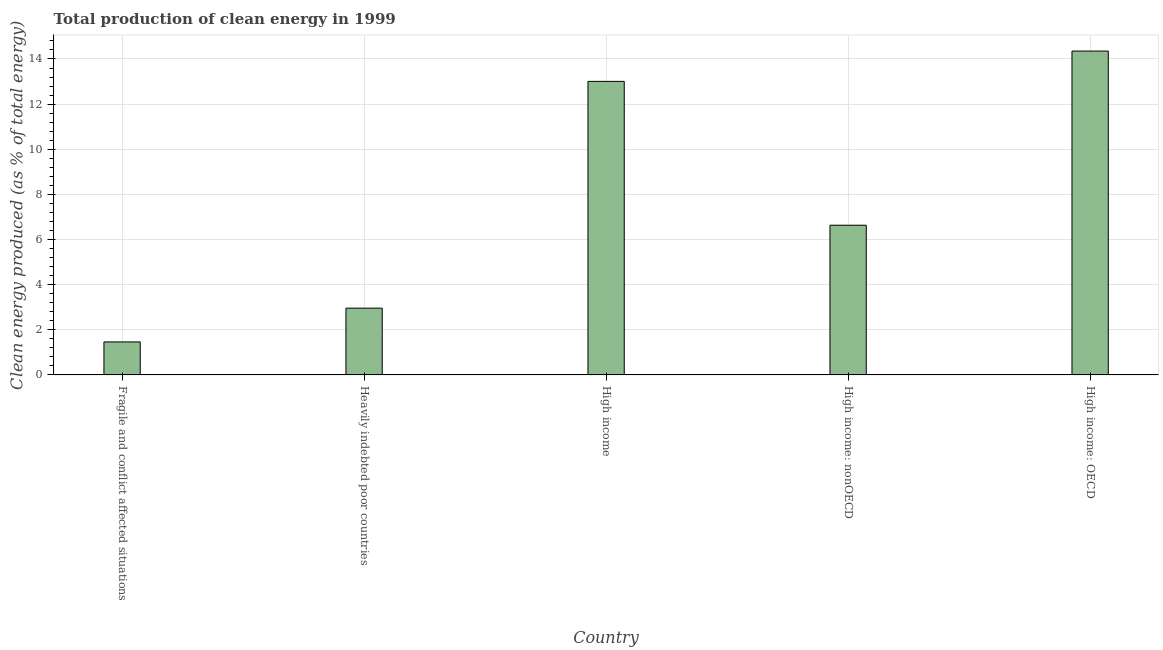Does the graph contain any zero values?
Offer a very short reply. No. What is the title of the graph?
Offer a terse response. Total production of clean energy in 1999. What is the label or title of the Y-axis?
Your answer should be very brief. Clean energy produced (as % of total energy). What is the production of clean energy in Heavily indebted poor countries?
Your response must be concise. 2.96. Across all countries, what is the maximum production of clean energy?
Your answer should be very brief. 14.35. Across all countries, what is the minimum production of clean energy?
Your answer should be compact. 1.46. In which country was the production of clean energy maximum?
Ensure brevity in your answer.  High income: OECD. In which country was the production of clean energy minimum?
Your response must be concise. Fragile and conflict affected situations. What is the sum of the production of clean energy?
Offer a very short reply. 38.41. What is the difference between the production of clean energy in Fragile and conflict affected situations and High income: nonOECD?
Your answer should be compact. -5.17. What is the average production of clean energy per country?
Ensure brevity in your answer.  7.68. What is the median production of clean energy?
Offer a terse response. 6.63. What is the ratio of the production of clean energy in High income to that in High income: nonOECD?
Provide a short and direct response. 1.96. Is the production of clean energy in Fragile and conflict affected situations less than that in Heavily indebted poor countries?
Ensure brevity in your answer.  Yes. Is the difference between the production of clean energy in High income and High income: OECD greater than the difference between any two countries?
Your answer should be very brief. No. What is the difference between the highest and the second highest production of clean energy?
Your answer should be very brief. 1.34. What is the difference between the highest and the lowest production of clean energy?
Offer a very short reply. 12.89. In how many countries, is the production of clean energy greater than the average production of clean energy taken over all countries?
Keep it short and to the point. 2. How many countries are there in the graph?
Your answer should be very brief. 5. What is the Clean energy produced (as % of total energy) in Fragile and conflict affected situations?
Offer a terse response. 1.46. What is the Clean energy produced (as % of total energy) in Heavily indebted poor countries?
Your response must be concise. 2.96. What is the Clean energy produced (as % of total energy) of High income?
Your answer should be very brief. 13.01. What is the Clean energy produced (as % of total energy) of High income: nonOECD?
Provide a succinct answer. 6.63. What is the Clean energy produced (as % of total energy) in High income: OECD?
Give a very brief answer. 14.35. What is the difference between the Clean energy produced (as % of total energy) in Fragile and conflict affected situations and Heavily indebted poor countries?
Your answer should be very brief. -1.5. What is the difference between the Clean energy produced (as % of total energy) in Fragile and conflict affected situations and High income?
Provide a short and direct response. -11.55. What is the difference between the Clean energy produced (as % of total energy) in Fragile and conflict affected situations and High income: nonOECD?
Your answer should be compact. -5.17. What is the difference between the Clean energy produced (as % of total energy) in Fragile and conflict affected situations and High income: OECD?
Give a very brief answer. -12.89. What is the difference between the Clean energy produced (as % of total energy) in Heavily indebted poor countries and High income?
Your response must be concise. -10.05. What is the difference between the Clean energy produced (as % of total energy) in Heavily indebted poor countries and High income: nonOECD?
Provide a short and direct response. -3.68. What is the difference between the Clean energy produced (as % of total energy) in Heavily indebted poor countries and High income: OECD?
Ensure brevity in your answer.  -11.39. What is the difference between the Clean energy produced (as % of total energy) in High income and High income: nonOECD?
Your answer should be compact. 6.37. What is the difference between the Clean energy produced (as % of total energy) in High income and High income: OECD?
Keep it short and to the point. -1.34. What is the difference between the Clean energy produced (as % of total energy) in High income: nonOECD and High income: OECD?
Ensure brevity in your answer.  -7.72. What is the ratio of the Clean energy produced (as % of total energy) in Fragile and conflict affected situations to that in Heavily indebted poor countries?
Give a very brief answer. 0.49. What is the ratio of the Clean energy produced (as % of total energy) in Fragile and conflict affected situations to that in High income?
Your answer should be very brief. 0.11. What is the ratio of the Clean energy produced (as % of total energy) in Fragile and conflict affected situations to that in High income: nonOECD?
Your answer should be compact. 0.22. What is the ratio of the Clean energy produced (as % of total energy) in Fragile and conflict affected situations to that in High income: OECD?
Make the answer very short. 0.1. What is the ratio of the Clean energy produced (as % of total energy) in Heavily indebted poor countries to that in High income?
Offer a very short reply. 0.23. What is the ratio of the Clean energy produced (as % of total energy) in Heavily indebted poor countries to that in High income: nonOECD?
Offer a terse response. 0.45. What is the ratio of the Clean energy produced (as % of total energy) in Heavily indebted poor countries to that in High income: OECD?
Make the answer very short. 0.21. What is the ratio of the Clean energy produced (as % of total energy) in High income to that in High income: nonOECD?
Ensure brevity in your answer.  1.96. What is the ratio of the Clean energy produced (as % of total energy) in High income to that in High income: OECD?
Provide a short and direct response. 0.91. What is the ratio of the Clean energy produced (as % of total energy) in High income: nonOECD to that in High income: OECD?
Your response must be concise. 0.46. 